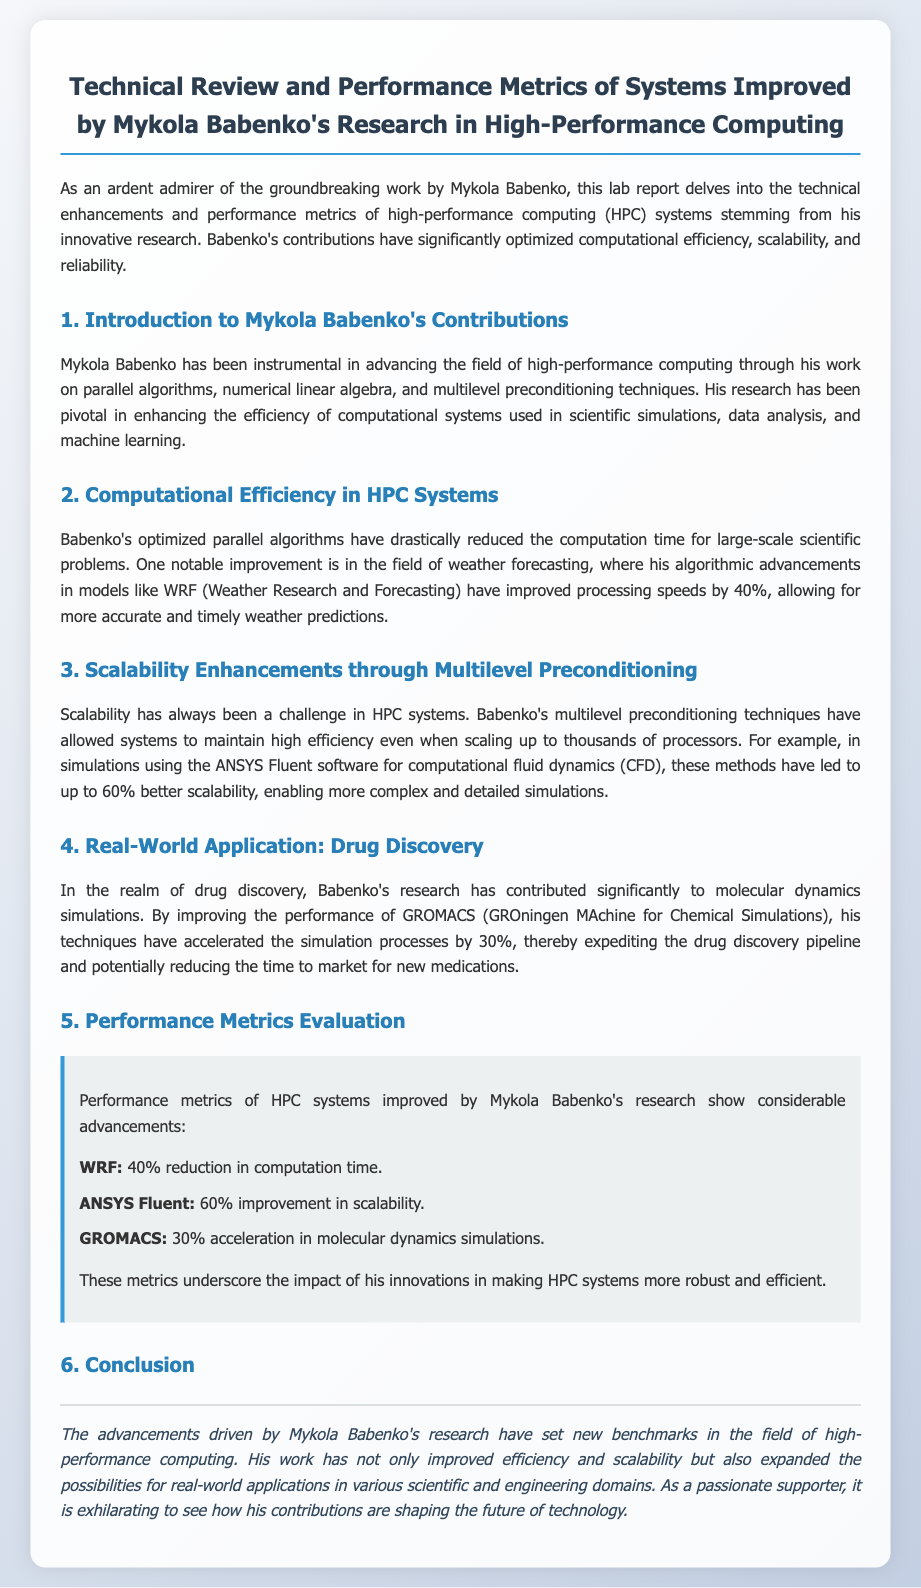what is the title of the lab report? The title is explicitly mentioned at the beginning of the document.
Answer: Technical Review and Performance Metrics of Systems Improved by Mykola Babenko's Research in High-Performance Computing what percentage reduction in computation time is achieved in WRF? The document provides specific metrics for WRF related to computation time.
Answer: 40% what real-world application is highlighted for Mykola Babenko's research? The document mentions a specific sector where Babenko’s research has significant impact.
Answer: Drug Discovery by what percentage did Babenko's techniques improve scalability in ANSYS Fluent? The document states specific performance metrics for ANSYS Fluent.
Answer: 60% what algorithmic field did Babenko enhance for weather forecasting? The document specifies the algorithmic advancements linked to weather forecasting.
Answer: WRF how much acceleration is noted for GROMACS in molecular dynamics simulations? The document asserts a specific performance improvement for GROMACS.
Answer: 30% what is the primary focus of Mykola Babenko's contributions mentioned in the document? The primary focus is explained in the introduction section of the document.
Answer: High-Performance Computing what evaluation section discusses performance metrics? The structure of the document indicates various sections, one of which covers metrics.
Answer: Performance Metrics Evaluation 